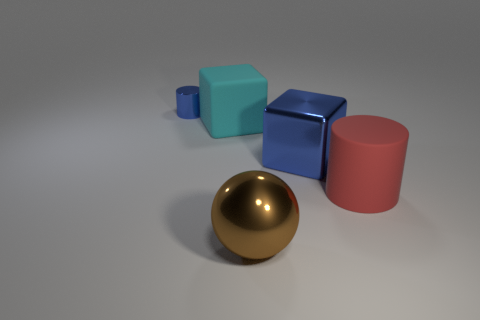What is the size of the thing that is the same color as the metallic cylinder?
Your answer should be very brief. Large. There is a large metal object in front of the metal object to the right of the ball; what is its shape?
Keep it short and to the point. Sphere. There is a matte thing behind the large rubber object that is to the right of the big cyan thing; are there any big rubber cylinders that are on the left side of it?
Your response must be concise. No. What size is the cylinder that is in front of the blue object that is to the right of the large cyan matte block?
Make the answer very short. Large. What number of other metallic things are the same color as the tiny object?
Your answer should be very brief. 1. What number of small blue metallic objects are the same shape as the red rubber thing?
Make the answer very short. 1. Is the shape of the tiny blue metal object the same as the big blue thing?
Offer a very short reply. No. Are there any blue objects made of the same material as the large brown ball?
Make the answer very short. Yes. There is a object that is both on the right side of the large sphere and on the left side of the big red matte cylinder; what color is it?
Make the answer very short. Blue. There is a large block that is in front of the large cyan matte cube; what is its material?
Your answer should be compact. Metal. 